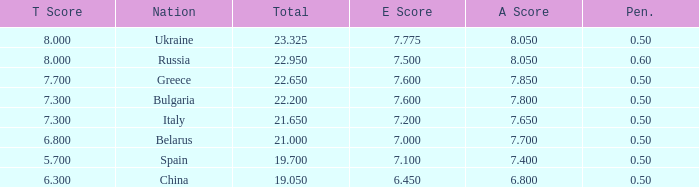What E score has the T score of 8 and a number smaller than 22.95? None. Could you parse the entire table? {'header': ['T Score', 'Nation', 'Total', 'E Score', 'A Score', 'Pen.'], 'rows': [['8.000', 'Ukraine', '23.325', '7.775', '8.050', '0.50'], ['8.000', 'Russia', '22.950', '7.500', '8.050', '0.60'], ['7.700', 'Greece', '22.650', '7.600', '7.850', '0.50'], ['7.300', 'Bulgaria', '22.200', '7.600', '7.800', '0.50'], ['7.300', 'Italy', '21.650', '7.200', '7.650', '0.50'], ['6.800', 'Belarus', '21.000', '7.000', '7.700', '0.50'], ['5.700', 'Spain', '19.700', '7.100', '7.400', '0.50'], ['6.300', 'China', '19.050', '6.450', '6.800', '0.50']]} 